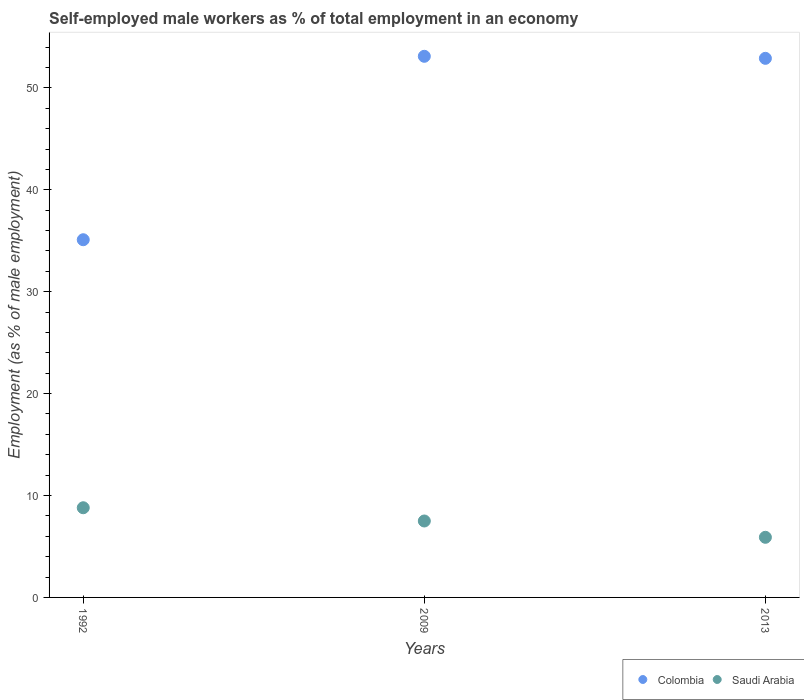What is the percentage of self-employed male workers in Saudi Arabia in 2009?
Keep it short and to the point. 7.5. Across all years, what is the maximum percentage of self-employed male workers in Colombia?
Your answer should be compact. 53.1. Across all years, what is the minimum percentage of self-employed male workers in Colombia?
Your answer should be very brief. 35.1. In which year was the percentage of self-employed male workers in Colombia maximum?
Give a very brief answer. 2009. What is the total percentage of self-employed male workers in Colombia in the graph?
Give a very brief answer. 141.1. What is the difference between the percentage of self-employed male workers in Saudi Arabia in 1992 and that in 2009?
Offer a terse response. 1.3. What is the difference between the percentage of self-employed male workers in Colombia in 1992 and the percentage of self-employed male workers in Saudi Arabia in 2013?
Offer a terse response. 29.2. What is the average percentage of self-employed male workers in Saudi Arabia per year?
Your response must be concise. 7.4. In the year 2009, what is the difference between the percentage of self-employed male workers in Saudi Arabia and percentage of self-employed male workers in Colombia?
Your response must be concise. -45.6. In how many years, is the percentage of self-employed male workers in Saudi Arabia greater than 8 %?
Make the answer very short. 1. What is the ratio of the percentage of self-employed male workers in Saudi Arabia in 1992 to that in 2013?
Offer a very short reply. 1.49. What is the difference between the highest and the second highest percentage of self-employed male workers in Colombia?
Provide a succinct answer. 0.2. In how many years, is the percentage of self-employed male workers in Colombia greater than the average percentage of self-employed male workers in Colombia taken over all years?
Ensure brevity in your answer.  2. Does the percentage of self-employed male workers in Colombia monotonically increase over the years?
Make the answer very short. No. How many dotlines are there?
Offer a very short reply. 2. Are the values on the major ticks of Y-axis written in scientific E-notation?
Your answer should be very brief. No. Does the graph contain any zero values?
Ensure brevity in your answer.  No. What is the title of the graph?
Make the answer very short. Self-employed male workers as % of total employment in an economy. What is the label or title of the Y-axis?
Provide a short and direct response. Employment (as % of male employment). What is the Employment (as % of male employment) of Colombia in 1992?
Your answer should be very brief. 35.1. What is the Employment (as % of male employment) of Saudi Arabia in 1992?
Offer a very short reply. 8.8. What is the Employment (as % of male employment) in Colombia in 2009?
Your response must be concise. 53.1. What is the Employment (as % of male employment) of Saudi Arabia in 2009?
Offer a terse response. 7.5. What is the Employment (as % of male employment) of Colombia in 2013?
Make the answer very short. 52.9. What is the Employment (as % of male employment) in Saudi Arabia in 2013?
Make the answer very short. 5.9. Across all years, what is the maximum Employment (as % of male employment) of Colombia?
Your answer should be compact. 53.1. Across all years, what is the maximum Employment (as % of male employment) in Saudi Arabia?
Your answer should be very brief. 8.8. Across all years, what is the minimum Employment (as % of male employment) of Colombia?
Keep it short and to the point. 35.1. Across all years, what is the minimum Employment (as % of male employment) in Saudi Arabia?
Offer a terse response. 5.9. What is the total Employment (as % of male employment) in Colombia in the graph?
Your answer should be very brief. 141.1. What is the total Employment (as % of male employment) of Saudi Arabia in the graph?
Your answer should be compact. 22.2. What is the difference between the Employment (as % of male employment) in Saudi Arabia in 1992 and that in 2009?
Provide a short and direct response. 1.3. What is the difference between the Employment (as % of male employment) in Colombia in 1992 and that in 2013?
Give a very brief answer. -17.8. What is the difference between the Employment (as % of male employment) in Colombia in 2009 and that in 2013?
Give a very brief answer. 0.2. What is the difference between the Employment (as % of male employment) of Colombia in 1992 and the Employment (as % of male employment) of Saudi Arabia in 2009?
Your response must be concise. 27.6. What is the difference between the Employment (as % of male employment) of Colombia in 1992 and the Employment (as % of male employment) of Saudi Arabia in 2013?
Offer a terse response. 29.2. What is the difference between the Employment (as % of male employment) in Colombia in 2009 and the Employment (as % of male employment) in Saudi Arabia in 2013?
Give a very brief answer. 47.2. What is the average Employment (as % of male employment) in Colombia per year?
Your response must be concise. 47.03. What is the average Employment (as % of male employment) in Saudi Arabia per year?
Your response must be concise. 7.4. In the year 1992, what is the difference between the Employment (as % of male employment) in Colombia and Employment (as % of male employment) in Saudi Arabia?
Offer a terse response. 26.3. In the year 2009, what is the difference between the Employment (as % of male employment) in Colombia and Employment (as % of male employment) in Saudi Arabia?
Give a very brief answer. 45.6. What is the ratio of the Employment (as % of male employment) of Colombia in 1992 to that in 2009?
Provide a short and direct response. 0.66. What is the ratio of the Employment (as % of male employment) of Saudi Arabia in 1992 to that in 2009?
Provide a short and direct response. 1.17. What is the ratio of the Employment (as % of male employment) in Colombia in 1992 to that in 2013?
Provide a succinct answer. 0.66. What is the ratio of the Employment (as % of male employment) of Saudi Arabia in 1992 to that in 2013?
Offer a very short reply. 1.49. What is the ratio of the Employment (as % of male employment) of Colombia in 2009 to that in 2013?
Provide a short and direct response. 1. What is the ratio of the Employment (as % of male employment) in Saudi Arabia in 2009 to that in 2013?
Provide a succinct answer. 1.27. What is the difference between the highest and the second highest Employment (as % of male employment) in Colombia?
Ensure brevity in your answer.  0.2. What is the difference between the highest and the lowest Employment (as % of male employment) in Saudi Arabia?
Keep it short and to the point. 2.9. 